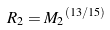Convert formula to latex. <formula><loc_0><loc_0><loc_500><loc_500>R _ { 2 } = { M _ { 2 } } ^ { ( 1 3 / 1 5 ) }</formula> 